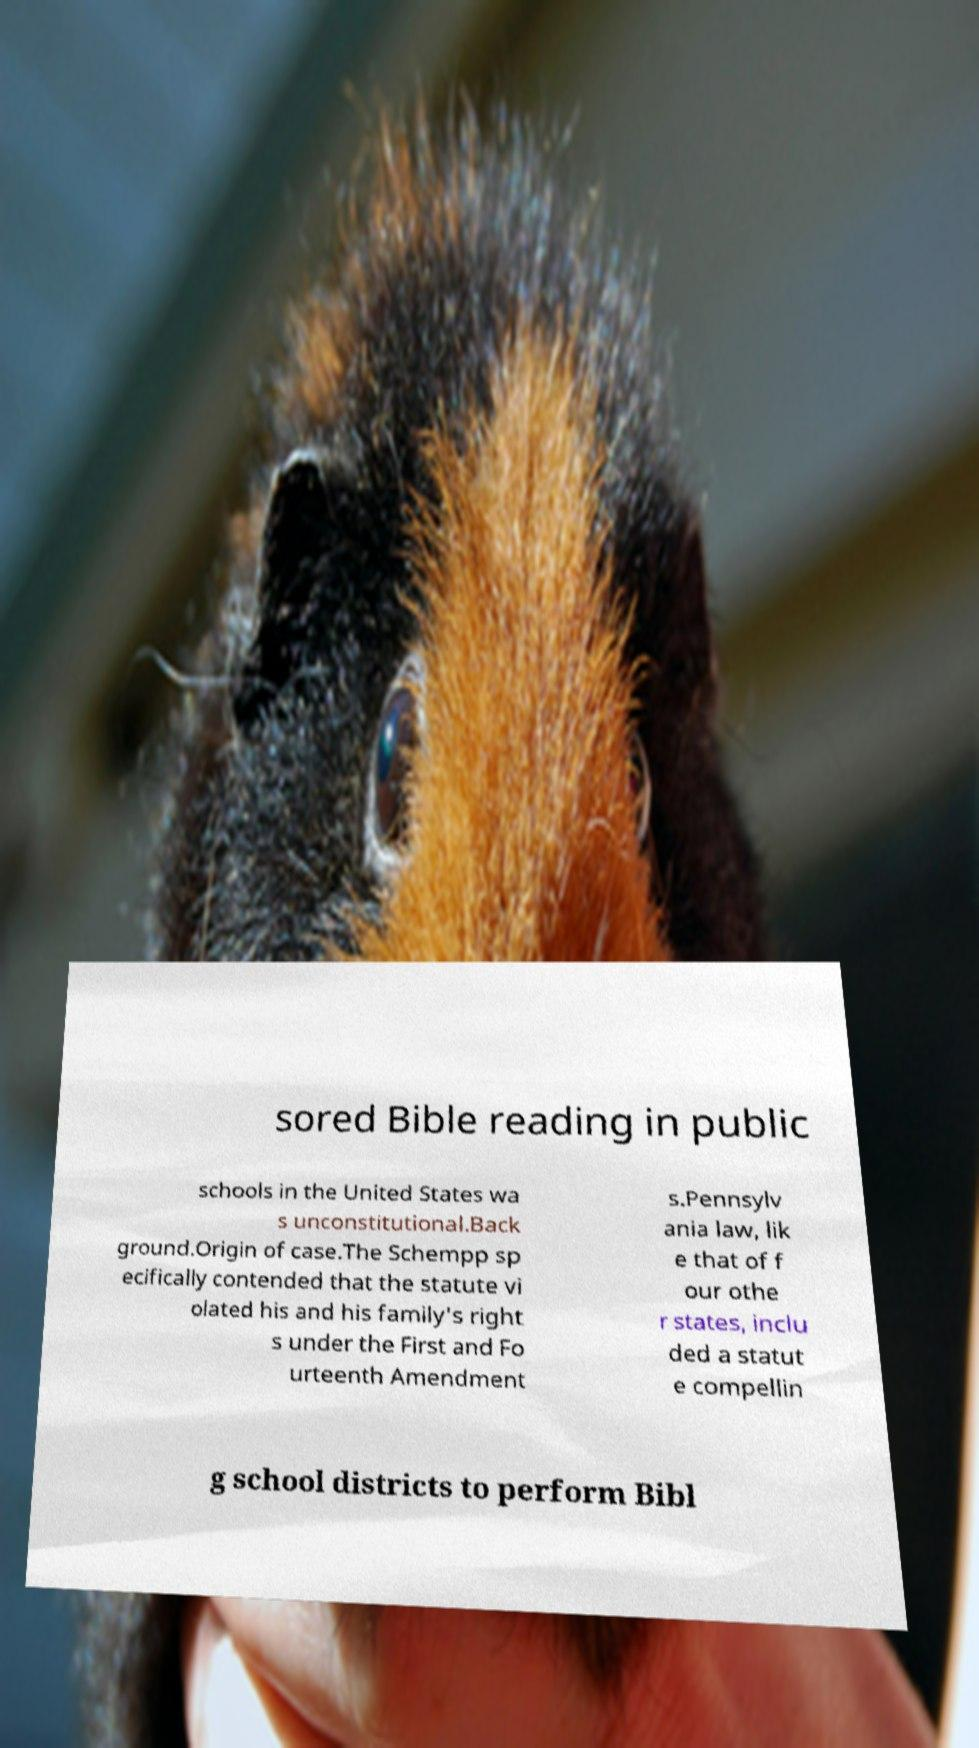For documentation purposes, I need the text within this image transcribed. Could you provide that? sored Bible reading in public schools in the United States wa s unconstitutional.Back ground.Origin of case.The Schempp sp ecifically contended that the statute vi olated his and his family's right s under the First and Fo urteenth Amendment s.Pennsylv ania law, lik e that of f our othe r states, inclu ded a statut e compellin g school districts to perform Bibl 